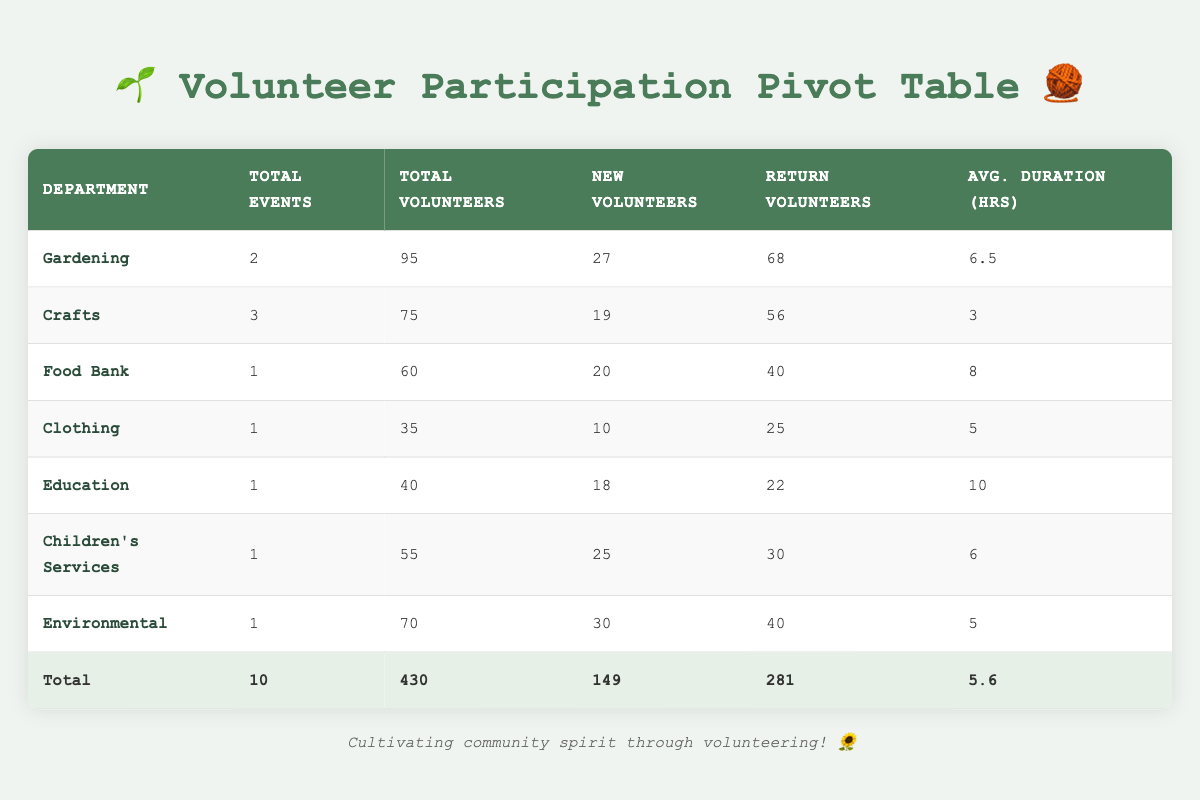What is the total number of volunteers for the "Knit for the Needy" event? The table lists the "Knit for the Needy" event under the Crafts department, with a total of 30 volunteers.
Answer: 30 Which department had the highest total volunteers? The Environmental department had 70 volunteers, which is higher than any other department listed in the table.
Answer: Environmental What is the average duration of events in the Crafts department? The Crafts department has three events with durations of 4, 3, and 2 hours. The sum is 4 + 3 + 2 = 9 hours. Dividing by 3 gives an average duration of 9/3 = 3 hours.
Answer: 3 Did the Gardening department have more new volunteers than return volunteers across all events? The Gardening department has a total of 27 new volunteers and 68 return volunteers across its two events, so it did not have more new volunteers than return volunteers.
Answer: No How many volunteers participated in the Thanksgiving Food Drive compared to the Annual Spring Plant Sale? The Thanksgiving Food Drive had 60 volunteers, while the Annual Spring Plant Sale had 45 volunteers, so 60 is greater than 45.
Answer: 60 is greater than 45 What is the total number of new volunteers across all events? The total number of new volunteers is calculated by summing the individual new volunteers from each event: 12 + 8 + 20 + 10 + 15 + 6 + 18 + 25 + 30 + 5 =  149.
Answer: 149 Which event in the Food Bank department had the longest duration? There is only one event in the Food Bank department, which is the Thanksgiving Food Drive with a duration of 8 hours. Therefore, it is also the longest duration for this department.
Answer: 8 hours Did the Children's Services department have any return volunteers? Yes, the Children's Services department had 30 return volunteers for the Holiday Toy Collection event.
Answer: Yes How does the total volunteer count of the Gardening department compare with the Clothing department? The Gardening department has 95 total volunteers (45 + 50) and the Clothing department has 35 total volunteers. Thus, Gardening has significantly more volunteers than Clothing.
Answer: Gardening has more volunteers than Clothing 